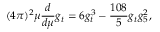Convert formula to latex. <formula><loc_0><loc_0><loc_500><loc_500>( 4 \pi ) ^ { 2 } \mu \frac { d } { d \mu } g _ { t } = 6 g _ { t } ^ { 3 } - \frac { 1 0 8 } { 5 } g _ { t } g _ { 5 } ^ { 2 } ,</formula> 